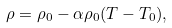<formula> <loc_0><loc_0><loc_500><loc_500>\rho = \rho _ { 0 } - \alpha \rho _ { 0 } ( T - T _ { 0 } ) ,</formula> 